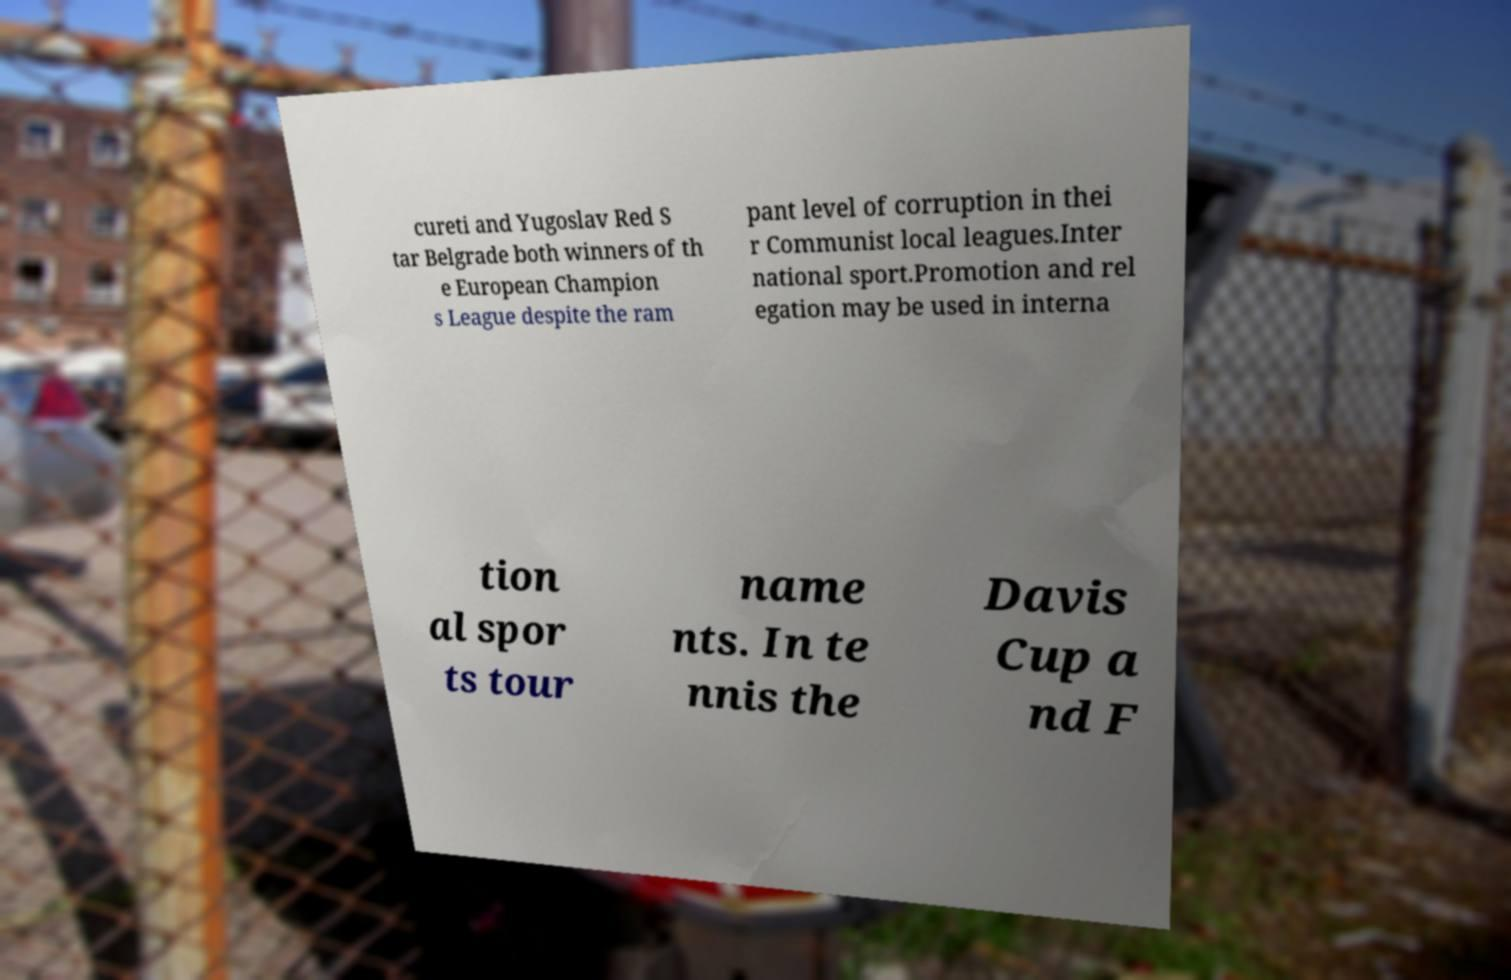There's text embedded in this image that I need extracted. Can you transcribe it verbatim? cureti and Yugoslav Red S tar Belgrade both winners of th e European Champion s League despite the ram pant level of corruption in thei r Communist local leagues.Inter national sport.Promotion and rel egation may be used in interna tion al spor ts tour name nts. In te nnis the Davis Cup a nd F 